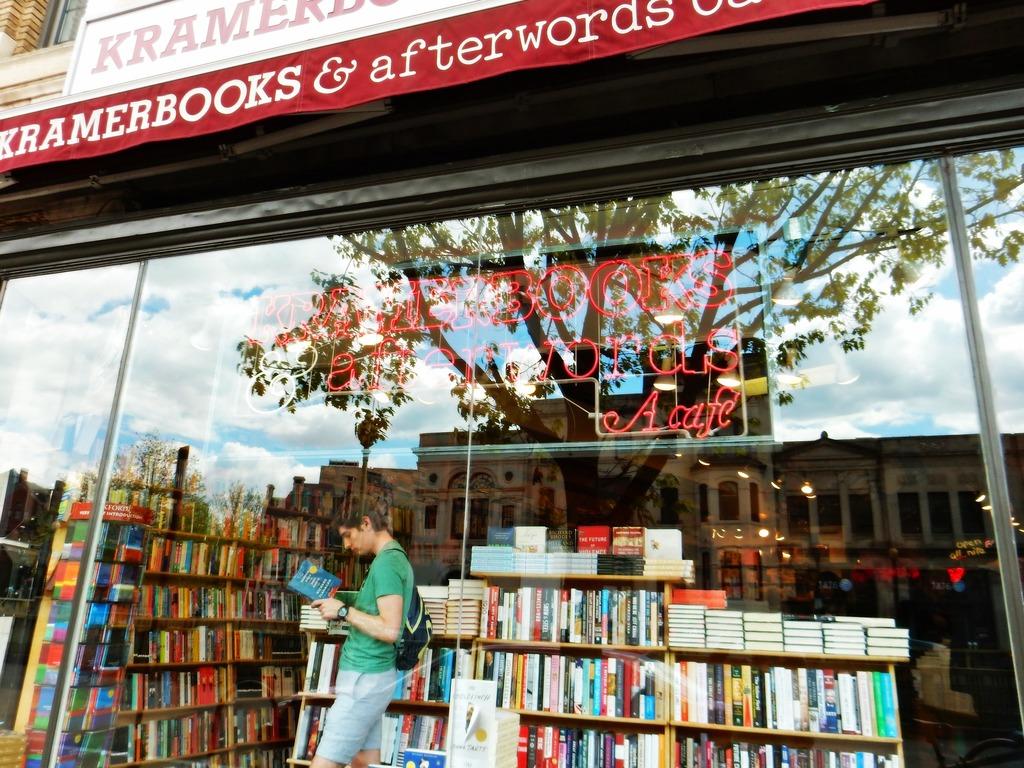What's the name of the book store?
Make the answer very short. Kramerbooks. In addition to books, what does the store offer?
Give a very brief answer. Cafe. 